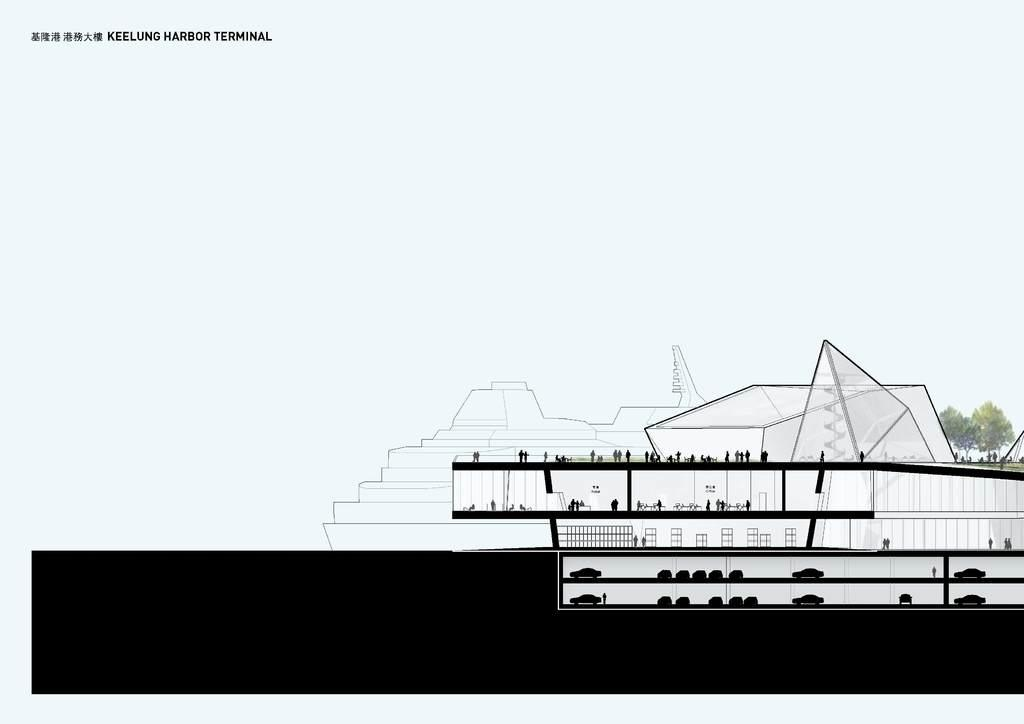What type of vessel is shown in the image? There is a Cruise Ferry in the image. What color are the trousers worn by the boy on the neck of the Cruise Ferry? There is no boy or trousers present on the neck of the Cruise Ferry in the image. 